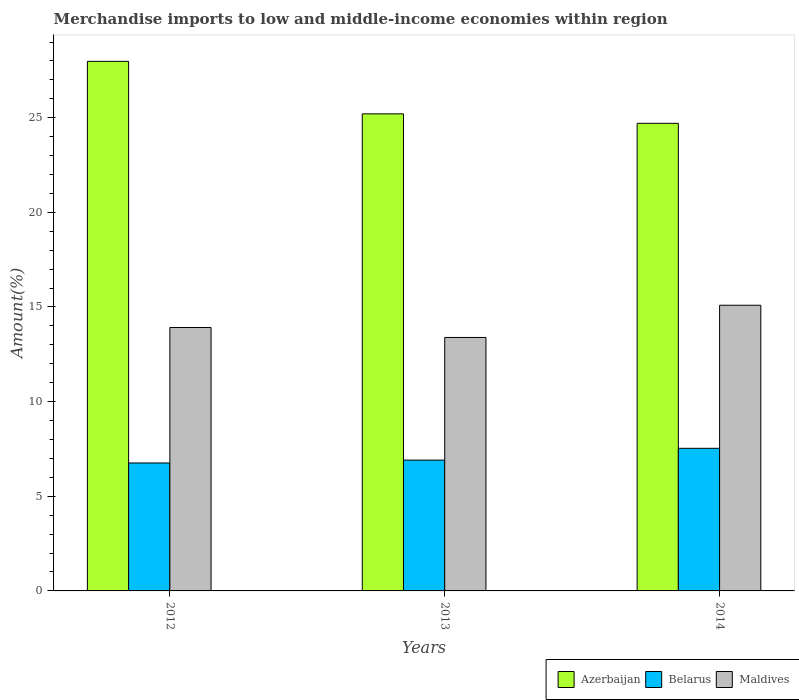How many bars are there on the 1st tick from the left?
Keep it short and to the point. 3. What is the label of the 1st group of bars from the left?
Your answer should be very brief. 2012. In how many cases, is the number of bars for a given year not equal to the number of legend labels?
Offer a terse response. 0. What is the percentage of amount earned from merchandise imports in Maldives in 2012?
Keep it short and to the point. 13.92. Across all years, what is the maximum percentage of amount earned from merchandise imports in Azerbaijan?
Provide a succinct answer. 27.98. Across all years, what is the minimum percentage of amount earned from merchandise imports in Maldives?
Your answer should be compact. 13.39. In which year was the percentage of amount earned from merchandise imports in Azerbaijan maximum?
Ensure brevity in your answer.  2012. What is the total percentage of amount earned from merchandise imports in Belarus in the graph?
Ensure brevity in your answer.  21.2. What is the difference between the percentage of amount earned from merchandise imports in Azerbaijan in 2013 and that in 2014?
Offer a very short reply. 0.5. What is the difference between the percentage of amount earned from merchandise imports in Belarus in 2012 and the percentage of amount earned from merchandise imports in Maldives in 2013?
Offer a terse response. -6.63. What is the average percentage of amount earned from merchandise imports in Belarus per year?
Your response must be concise. 7.07. In the year 2013, what is the difference between the percentage of amount earned from merchandise imports in Maldives and percentage of amount earned from merchandise imports in Azerbaijan?
Ensure brevity in your answer.  -11.81. In how many years, is the percentage of amount earned from merchandise imports in Maldives greater than 24 %?
Give a very brief answer. 0. What is the ratio of the percentage of amount earned from merchandise imports in Maldives in 2012 to that in 2014?
Your answer should be compact. 0.92. What is the difference between the highest and the second highest percentage of amount earned from merchandise imports in Maldives?
Ensure brevity in your answer.  1.18. What is the difference between the highest and the lowest percentage of amount earned from merchandise imports in Belarus?
Offer a very short reply. 0.77. In how many years, is the percentage of amount earned from merchandise imports in Belarus greater than the average percentage of amount earned from merchandise imports in Belarus taken over all years?
Your answer should be compact. 1. What does the 2nd bar from the left in 2013 represents?
Offer a very short reply. Belarus. What does the 1st bar from the right in 2012 represents?
Make the answer very short. Maldives. How many bars are there?
Offer a terse response. 9. Are all the bars in the graph horizontal?
Keep it short and to the point. No. Are the values on the major ticks of Y-axis written in scientific E-notation?
Make the answer very short. No. Does the graph contain grids?
Provide a succinct answer. No. How many legend labels are there?
Ensure brevity in your answer.  3. What is the title of the graph?
Provide a short and direct response. Merchandise imports to low and middle-income economies within region. Does "Fiji" appear as one of the legend labels in the graph?
Your answer should be compact. No. What is the label or title of the X-axis?
Your answer should be very brief. Years. What is the label or title of the Y-axis?
Offer a terse response. Amount(%). What is the Amount(%) of Azerbaijan in 2012?
Your answer should be compact. 27.98. What is the Amount(%) of Belarus in 2012?
Provide a short and direct response. 6.76. What is the Amount(%) of Maldives in 2012?
Make the answer very short. 13.92. What is the Amount(%) in Azerbaijan in 2013?
Ensure brevity in your answer.  25.2. What is the Amount(%) of Belarus in 2013?
Make the answer very short. 6.91. What is the Amount(%) in Maldives in 2013?
Offer a terse response. 13.39. What is the Amount(%) of Azerbaijan in 2014?
Provide a succinct answer. 24.7. What is the Amount(%) of Belarus in 2014?
Offer a terse response. 7.53. What is the Amount(%) in Maldives in 2014?
Your answer should be very brief. 15.09. Across all years, what is the maximum Amount(%) of Azerbaijan?
Provide a succinct answer. 27.98. Across all years, what is the maximum Amount(%) in Belarus?
Offer a terse response. 7.53. Across all years, what is the maximum Amount(%) of Maldives?
Your response must be concise. 15.09. Across all years, what is the minimum Amount(%) in Azerbaijan?
Your answer should be very brief. 24.7. Across all years, what is the minimum Amount(%) of Belarus?
Your answer should be very brief. 6.76. Across all years, what is the minimum Amount(%) of Maldives?
Your answer should be compact. 13.39. What is the total Amount(%) of Azerbaijan in the graph?
Provide a short and direct response. 77.89. What is the total Amount(%) of Belarus in the graph?
Make the answer very short. 21.2. What is the total Amount(%) in Maldives in the graph?
Make the answer very short. 42.4. What is the difference between the Amount(%) of Azerbaijan in 2012 and that in 2013?
Keep it short and to the point. 2.77. What is the difference between the Amount(%) in Belarus in 2012 and that in 2013?
Give a very brief answer. -0.15. What is the difference between the Amount(%) in Maldives in 2012 and that in 2013?
Your response must be concise. 0.53. What is the difference between the Amount(%) in Azerbaijan in 2012 and that in 2014?
Your response must be concise. 3.27. What is the difference between the Amount(%) of Belarus in 2012 and that in 2014?
Your response must be concise. -0.77. What is the difference between the Amount(%) of Maldives in 2012 and that in 2014?
Your response must be concise. -1.18. What is the difference between the Amount(%) of Azerbaijan in 2013 and that in 2014?
Offer a very short reply. 0.5. What is the difference between the Amount(%) of Belarus in 2013 and that in 2014?
Your answer should be very brief. -0.62. What is the difference between the Amount(%) of Maldives in 2013 and that in 2014?
Offer a terse response. -1.7. What is the difference between the Amount(%) of Azerbaijan in 2012 and the Amount(%) of Belarus in 2013?
Offer a terse response. 21.07. What is the difference between the Amount(%) of Azerbaijan in 2012 and the Amount(%) of Maldives in 2013?
Keep it short and to the point. 14.59. What is the difference between the Amount(%) of Belarus in 2012 and the Amount(%) of Maldives in 2013?
Your answer should be very brief. -6.63. What is the difference between the Amount(%) of Azerbaijan in 2012 and the Amount(%) of Belarus in 2014?
Provide a succinct answer. 20.44. What is the difference between the Amount(%) of Azerbaijan in 2012 and the Amount(%) of Maldives in 2014?
Offer a very short reply. 12.89. What is the difference between the Amount(%) of Belarus in 2012 and the Amount(%) of Maldives in 2014?
Ensure brevity in your answer.  -8.33. What is the difference between the Amount(%) of Azerbaijan in 2013 and the Amount(%) of Belarus in 2014?
Ensure brevity in your answer.  17.67. What is the difference between the Amount(%) in Azerbaijan in 2013 and the Amount(%) in Maldives in 2014?
Offer a terse response. 10.11. What is the difference between the Amount(%) in Belarus in 2013 and the Amount(%) in Maldives in 2014?
Your answer should be compact. -8.18. What is the average Amount(%) of Azerbaijan per year?
Your response must be concise. 25.96. What is the average Amount(%) of Belarus per year?
Make the answer very short. 7.07. What is the average Amount(%) in Maldives per year?
Your response must be concise. 14.13. In the year 2012, what is the difference between the Amount(%) of Azerbaijan and Amount(%) of Belarus?
Your answer should be compact. 21.22. In the year 2012, what is the difference between the Amount(%) of Azerbaijan and Amount(%) of Maldives?
Keep it short and to the point. 14.06. In the year 2012, what is the difference between the Amount(%) of Belarus and Amount(%) of Maldives?
Make the answer very short. -7.16. In the year 2013, what is the difference between the Amount(%) of Azerbaijan and Amount(%) of Belarus?
Make the answer very short. 18.29. In the year 2013, what is the difference between the Amount(%) in Azerbaijan and Amount(%) in Maldives?
Give a very brief answer. 11.81. In the year 2013, what is the difference between the Amount(%) in Belarus and Amount(%) in Maldives?
Your answer should be very brief. -6.48. In the year 2014, what is the difference between the Amount(%) in Azerbaijan and Amount(%) in Belarus?
Your answer should be compact. 17.17. In the year 2014, what is the difference between the Amount(%) in Azerbaijan and Amount(%) in Maldives?
Your answer should be compact. 9.61. In the year 2014, what is the difference between the Amount(%) in Belarus and Amount(%) in Maldives?
Offer a terse response. -7.56. What is the ratio of the Amount(%) of Azerbaijan in 2012 to that in 2013?
Offer a terse response. 1.11. What is the ratio of the Amount(%) in Belarus in 2012 to that in 2013?
Offer a terse response. 0.98. What is the ratio of the Amount(%) in Maldives in 2012 to that in 2013?
Your response must be concise. 1.04. What is the ratio of the Amount(%) of Azerbaijan in 2012 to that in 2014?
Offer a very short reply. 1.13. What is the ratio of the Amount(%) in Belarus in 2012 to that in 2014?
Your response must be concise. 0.9. What is the ratio of the Amount(%) of Maldives in 2012 to that in 2014?
Keep it short and to the point. 0.92. What is the ratio of the Amount(%) in Azerbaijan in 2013 to that in 2014?
Keep it short and to the point. 1.02. What is the ratio of the Amount(%) in Belarus in 2013 to that in 2014?
Make the answer very short. 0.92. What is the ratio of the Amount(%) in Maldives in 2013 to that in 2014?
Offer a terse response. 0.89. What is the difference between the highest and the second highest Amount(%) in Azerbaijan?
Make the answer very short. 2.77. What is the difference between the highest and the second highest Amount(%) in Belarus?
Your response must be concise. 0.62. What is the difference between the highest and the second highest Amount(%) of Maldives?
Make the answer very short. 1.18. What is the difference between the highest and the lowest Amount(%) of Azerbaijan?
Make the answer very short. 3.27. What is the difference between the highest and the lowest Amount(%) of Belarus?
Ensure brevity in your answer.  0.77. What is the difference between the highest and the lowest Amount(%) of Maldives?
Your response must be concise. 1.7. 